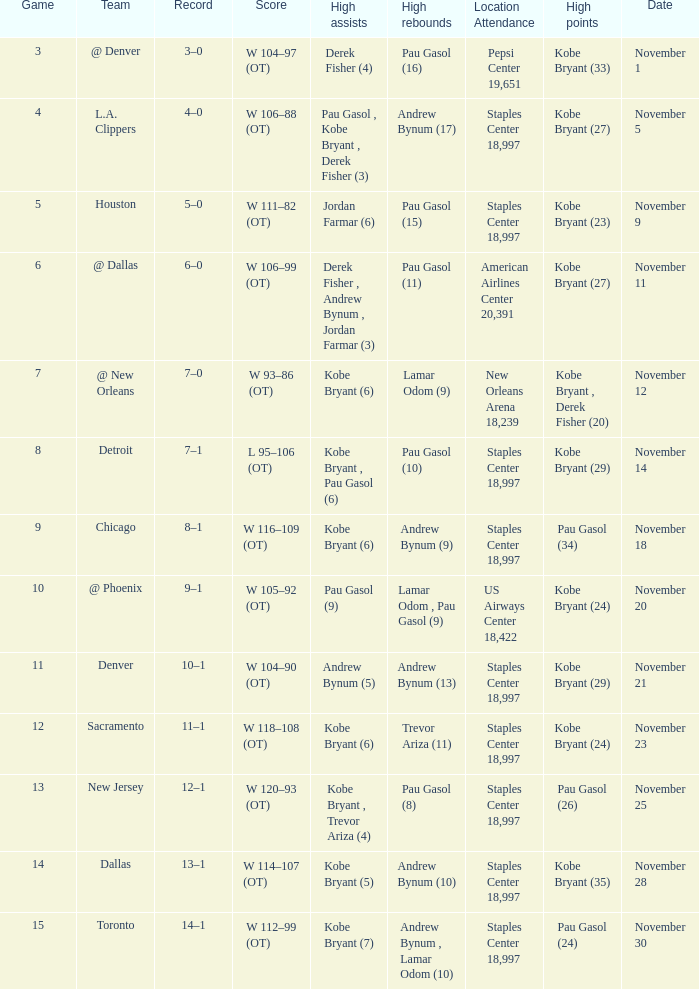What is High Assists, when High Points is "Kobe Bryant (27)", and when High Rebounds is "Pau Gasol (11)"? Derek Fisher , Andrew Bynum , Jordan Farmar (3). 